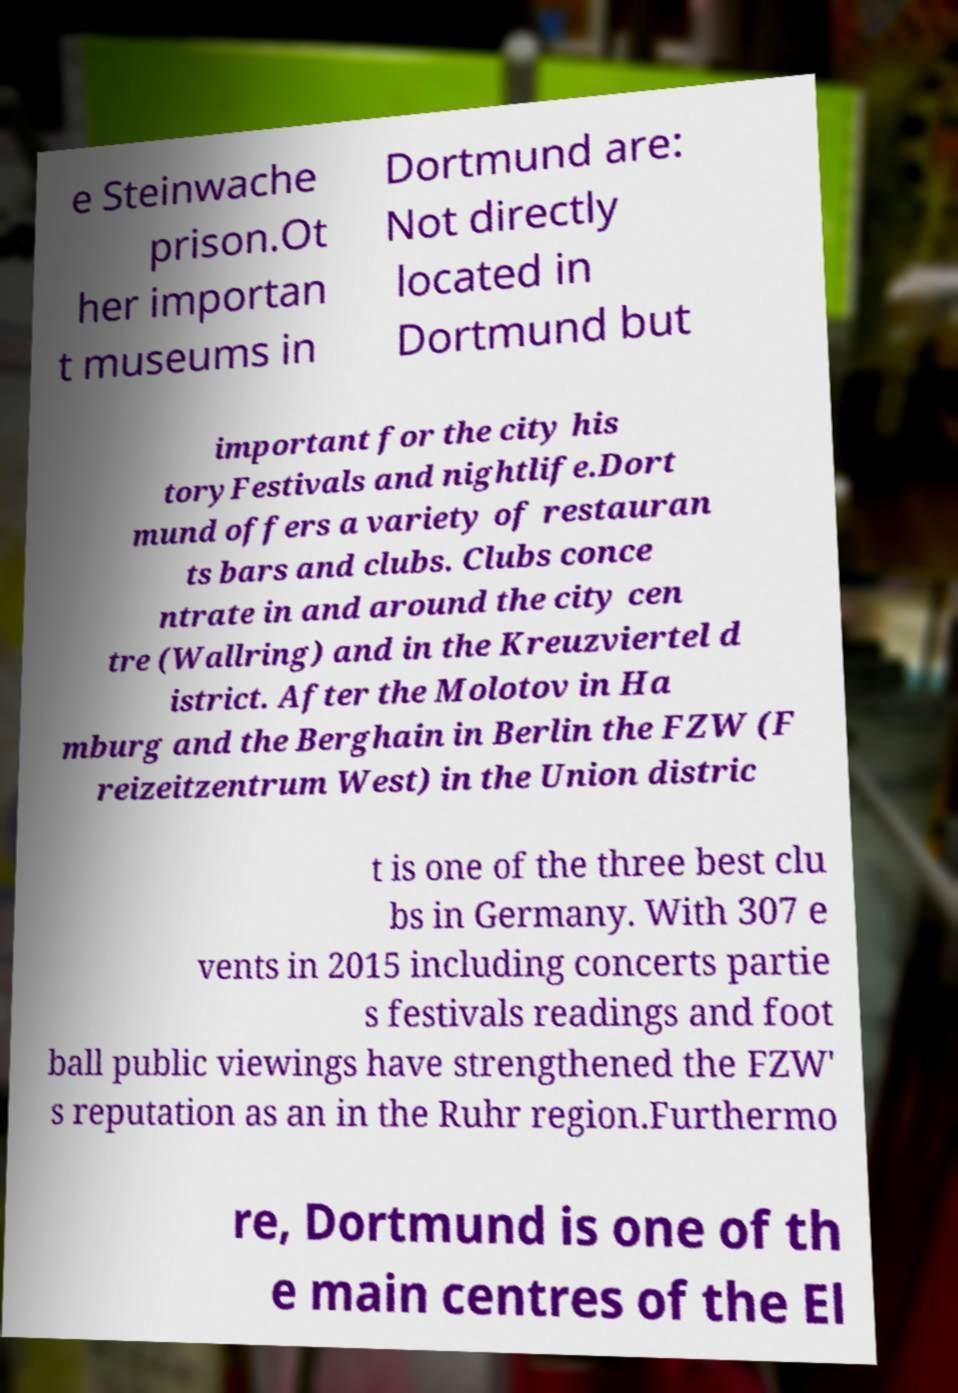Can you accurately transcribe the text from the provided image for me? e Steinwache prison.Ot her importan t museums in Dortmund are: Not directly located in Dortmund but important for the city his toryFestivals and nightlife.Dort mund offers a variety of restauran ts bars and clubs. Clubs conce ntrate in and around the city cen tre (Wallring) and in the Kreuzviertel d istrict. After the Molotov in Ha mburg and the Berghain in Berlin the FZW (F reizeitzentrum West) in the Union distric t is one of the three best clu bs in Germany. With 307 e vents in 2015 including concerts partie s festivals readings and foot ball public viewings have strengthened the FZW' s reputation as an in the Ruhr region.Furthermo re, Dortmund is one of th e main centres of the El 